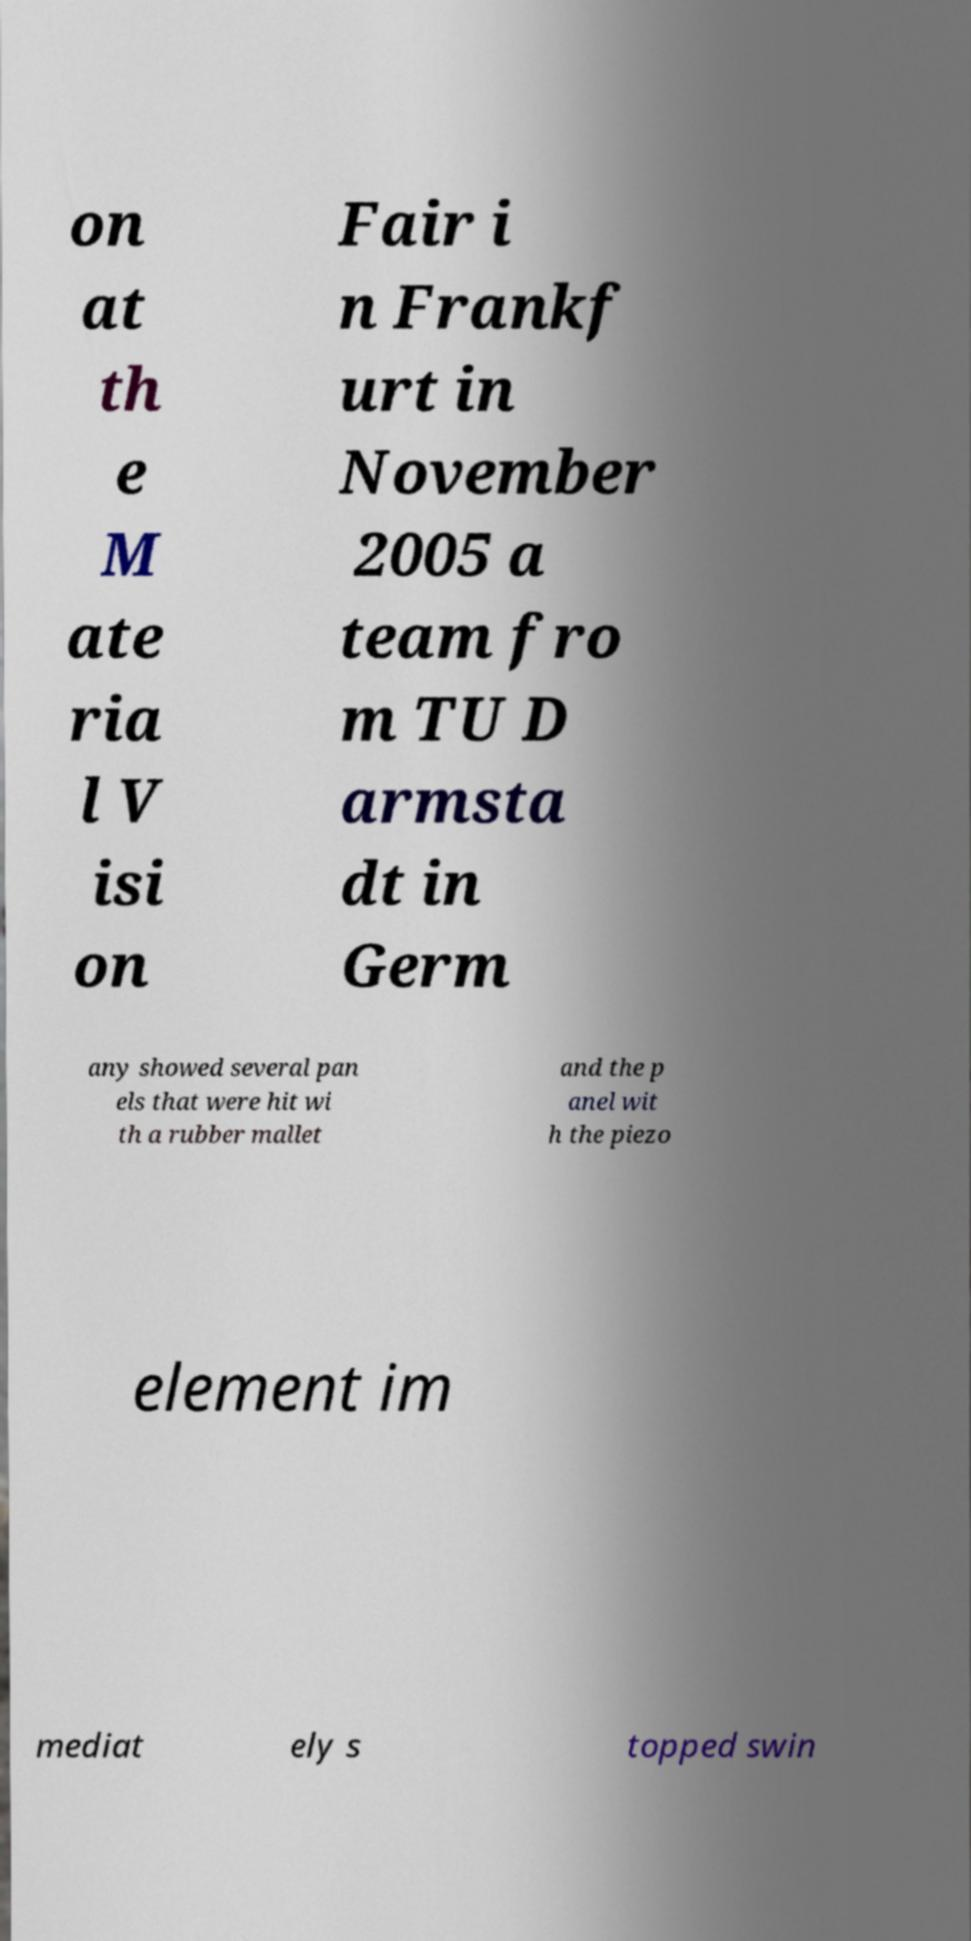I need the written content from this picture converted into text. Can you do that? on at th e M ate ria l V isi on Fair i n Frankf urt in November 2005 a team fro m TU D armsta dt in Germ any showed several pan els that were hit wi th a rubber mallet and the p anel wit h the piezo element im mediat ely s topped swin 